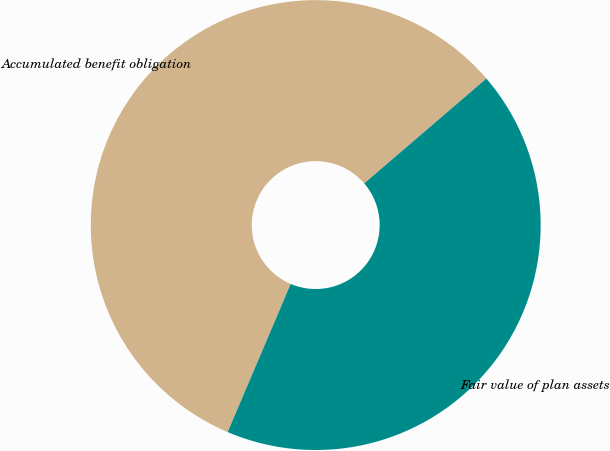Convert chart to OTSL. <chart><loc_0><loc_0><loc_500><loc_500><pie_chart><fcel>Accumulated benefit obligation<fcel>Fair value of plan assets<nl><fcel>57.31%<fcel>42.69%<nl></chart> 